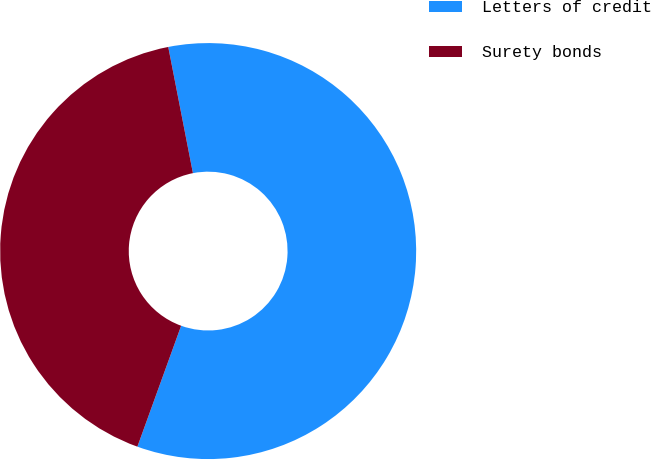Convert chart to OTSL. <chart><loc_0><loc_0><loc_500><loc_500><pie_chart><fcel>Letters of credit<fcel>Surety bonds<nl><fcel>58.6%<fcel>41.4%<nl></chart> 